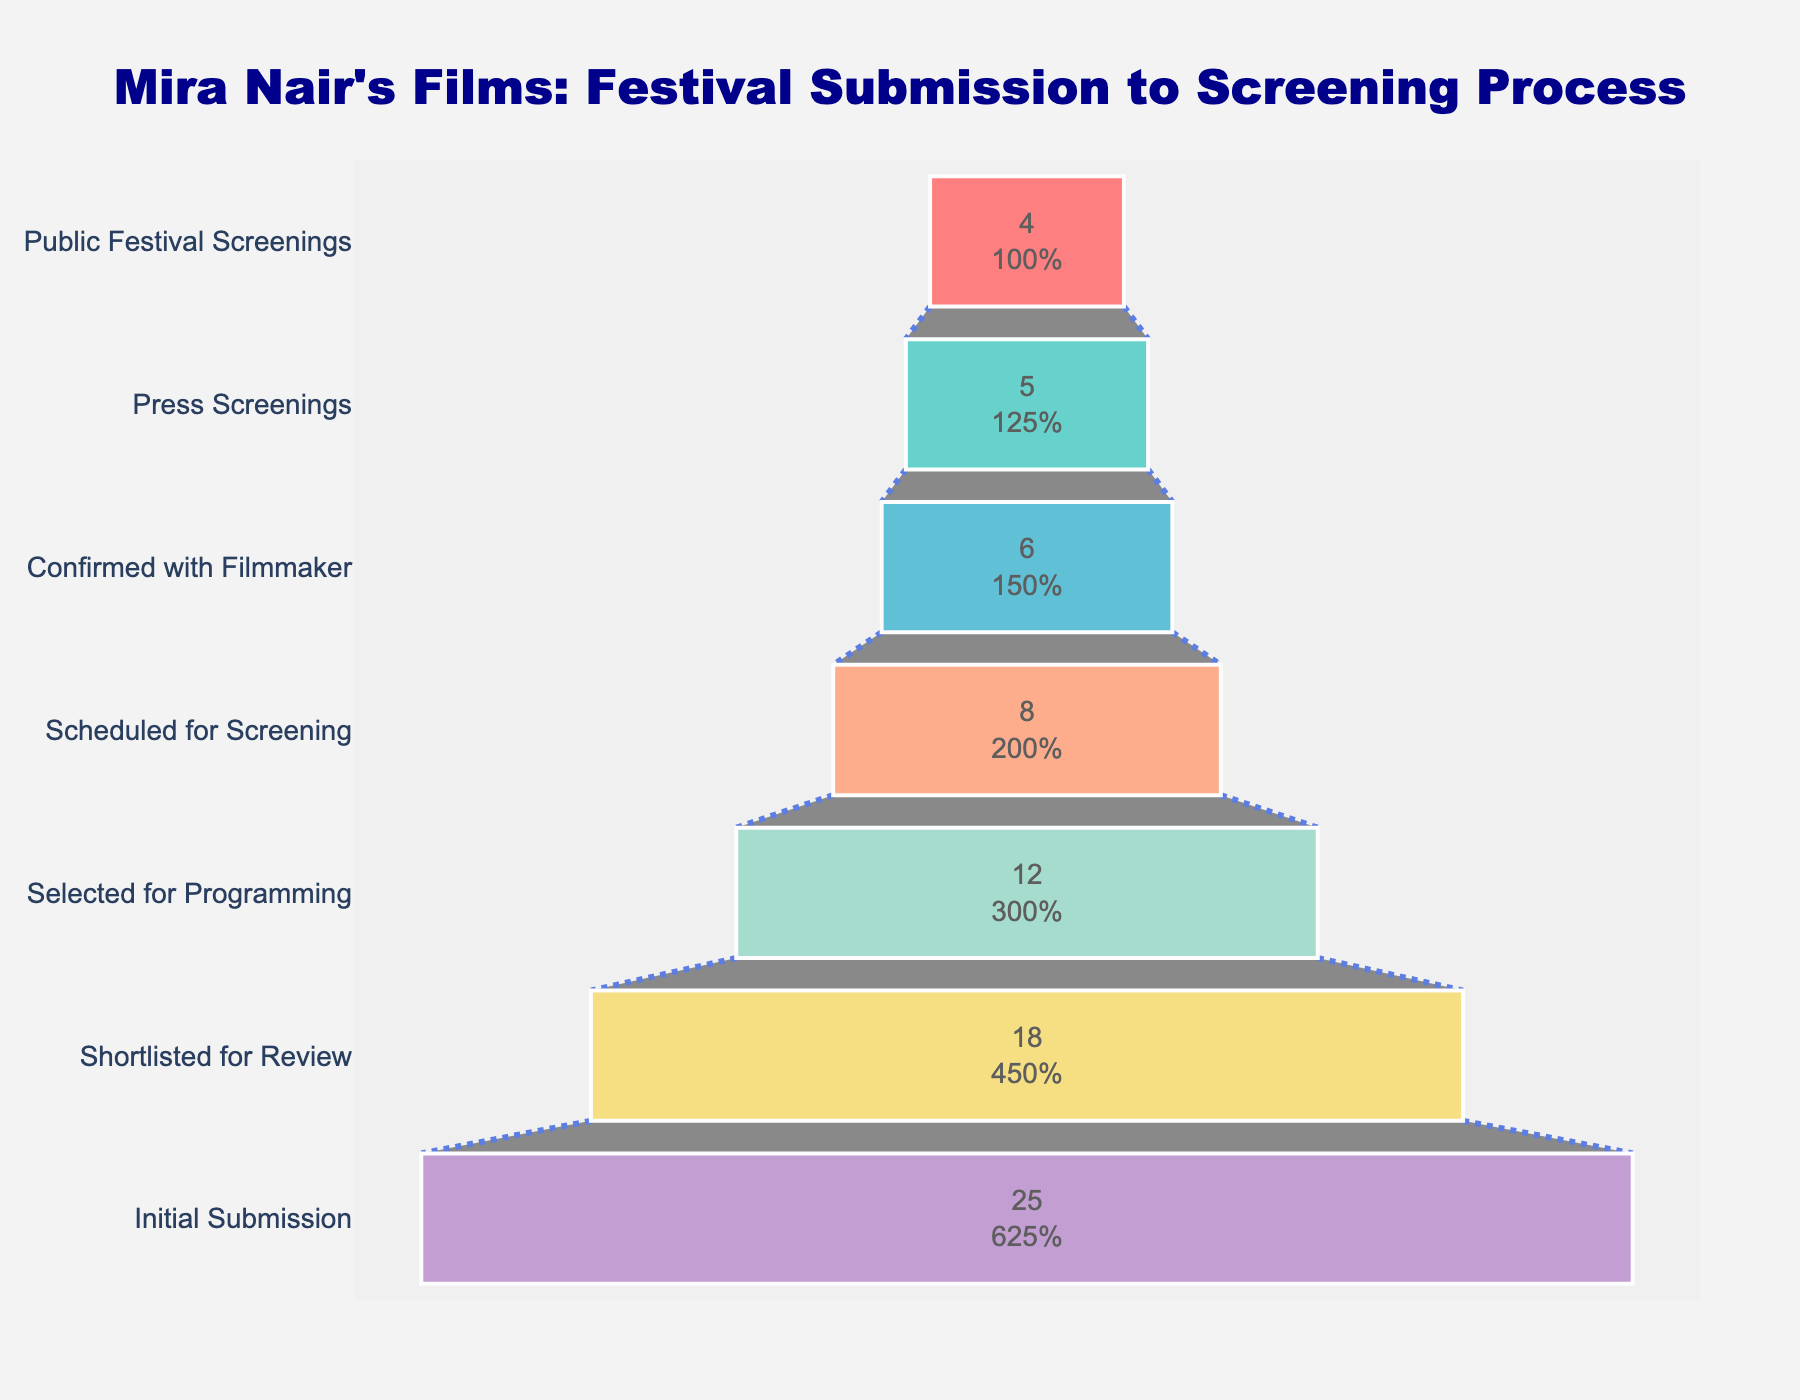How many films were initially submitted to the festival? This question only requires referencing the first (bottom-most) bar in the funnel chart, which represents the initial number of film submissions.
Answer: 25 How many films made it to the public festival screenings stage? Look at the top-most bar in the funnel chart to see how many films reached the public festival screenings stage.
Answer: 4 What percentage of films moved from the initial submission to being confirmed with the filmmaker? First, identify the number of films at the initial submission stage (25) and the number confirmed with the filmmaker (6). Calculate the percentage: (6/25) * 100%.
Answer: 24% Which stage had the largest drop in the number of films? Note the changes in the number of films at each stage by examining the length of each bar. The largest drop is between the initial submission (25 films) and the shortlisted for review stage (18 films).
Answer: From initial submission to shortlisted for review By how many films did the number reduce from the selected for programming stage to the scheduled for screening stage? Look at the number of films at the “Selected for Programming” (12) and “Scheduled for Screening” stages (8), then find the difference: 12 - 8.
Answer: 4 What is the ratio of films that underwent press screenings to films that had public festival screenings? Identify the number of films at the press screenings stage (5) and at the public festival screenings stage (4). Then calculate the ratio of 5 to 4.
Answer: 5:4 What is the proportion of shortlisted films that were selected for programming? From the chart, note the number of films shortlisted for review (18) and those selected for programming (12). Calculate the proportion: 12/18.
Answer: 2/3 How many steps are there between the initial submission and the public festival screenings? Count the number of distinct stages in the funnel chart from initial submission to public festival screenings.
Answer: 7 Are there more films confirmed with the filmmaker or at press screenings? Compare the number of films at the “Confirmed with Filmmaker" stage (6) to those at the “Press Screenings” stage (5).
Answer: Confirmed with Filmmaker What percentage of selected for programming films end up in public festival screenings? Check the number of films at the selected for programming stage (12) and public festival screenings stage (4). Calculate the percentage: (4/12) * 100%.
Answer: 33.3% 